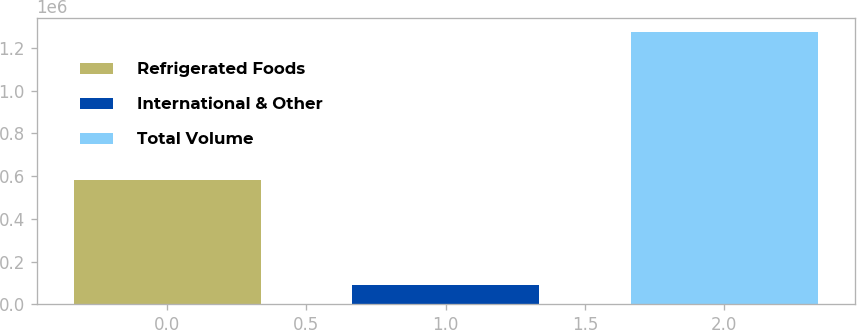Convert chart. <chart><loc_0><loc_0><loc_500><loc_500><bar_chart><fcel>Refrigerated Foods<fcel>International & Other<fcel>Total Volume<nl><fcel>583526<fcel>91414<fcel>1.27527e+06<nl></chart> 